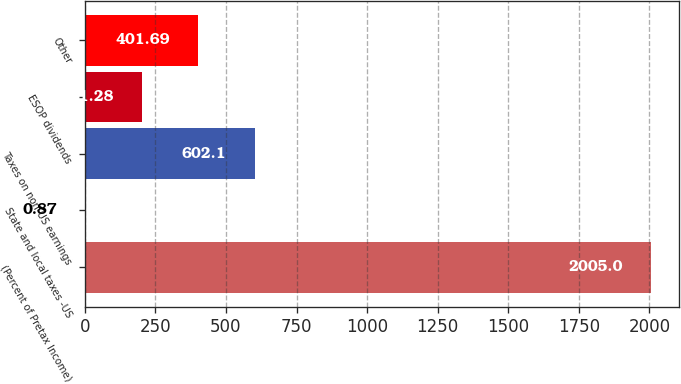Convert chart to OTSL. <chart><loc_0><loc_0><loc_500><loc_500><bar_chart><fcel>(Percent of Pretax Income)<fcel>State and local taxes -US<fcel>Taxes on non-US earnings<fcel>ESOP dividends<fcel>Other<nl><fcel>2005<fcel>0.87<fcel>602.1<fcel>201.28<fcel>401.69<nl></chart> 